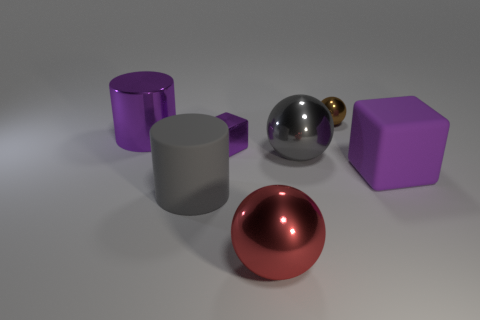What is the material of the large red sphere?
Offer a very short reply. Metal. Do the shiny block and the brown object have the same size?
Offer a very short reply. Yes. How many cubes are blue rubber objects or brown shiny objects?
Keep it short and to the point. 0. There is a tiny object that is right of the ball in front of the purple matte object; what is its color?
Make the answer very short. Brown. Are there fewer large metal spheres that are on the right side of the large gray metal ball than big metallic things left of the large gray matte object?
Provide a succinct answer. Yes. There is a rubber block; is its size the same as the cube that is on the left side of the brown thing?
Your answer should be very brief. No. What shape is the metal thing that is both behind the small purple metal cube and in front of the brown metal sphere?
Ensure brevity in your answer.  Cylinder. What is the size of the gray cylinder that is made of the same material as the big cube?
Your answer should be very brief. Large. What number of shiny objects are to the left of the gray thing in front of the large cube?
Make the answer very short. 1. Do the big purple object in front of the large purple cylinder and the gray cylinder have the same material?
Your response must be concise. Yes. 